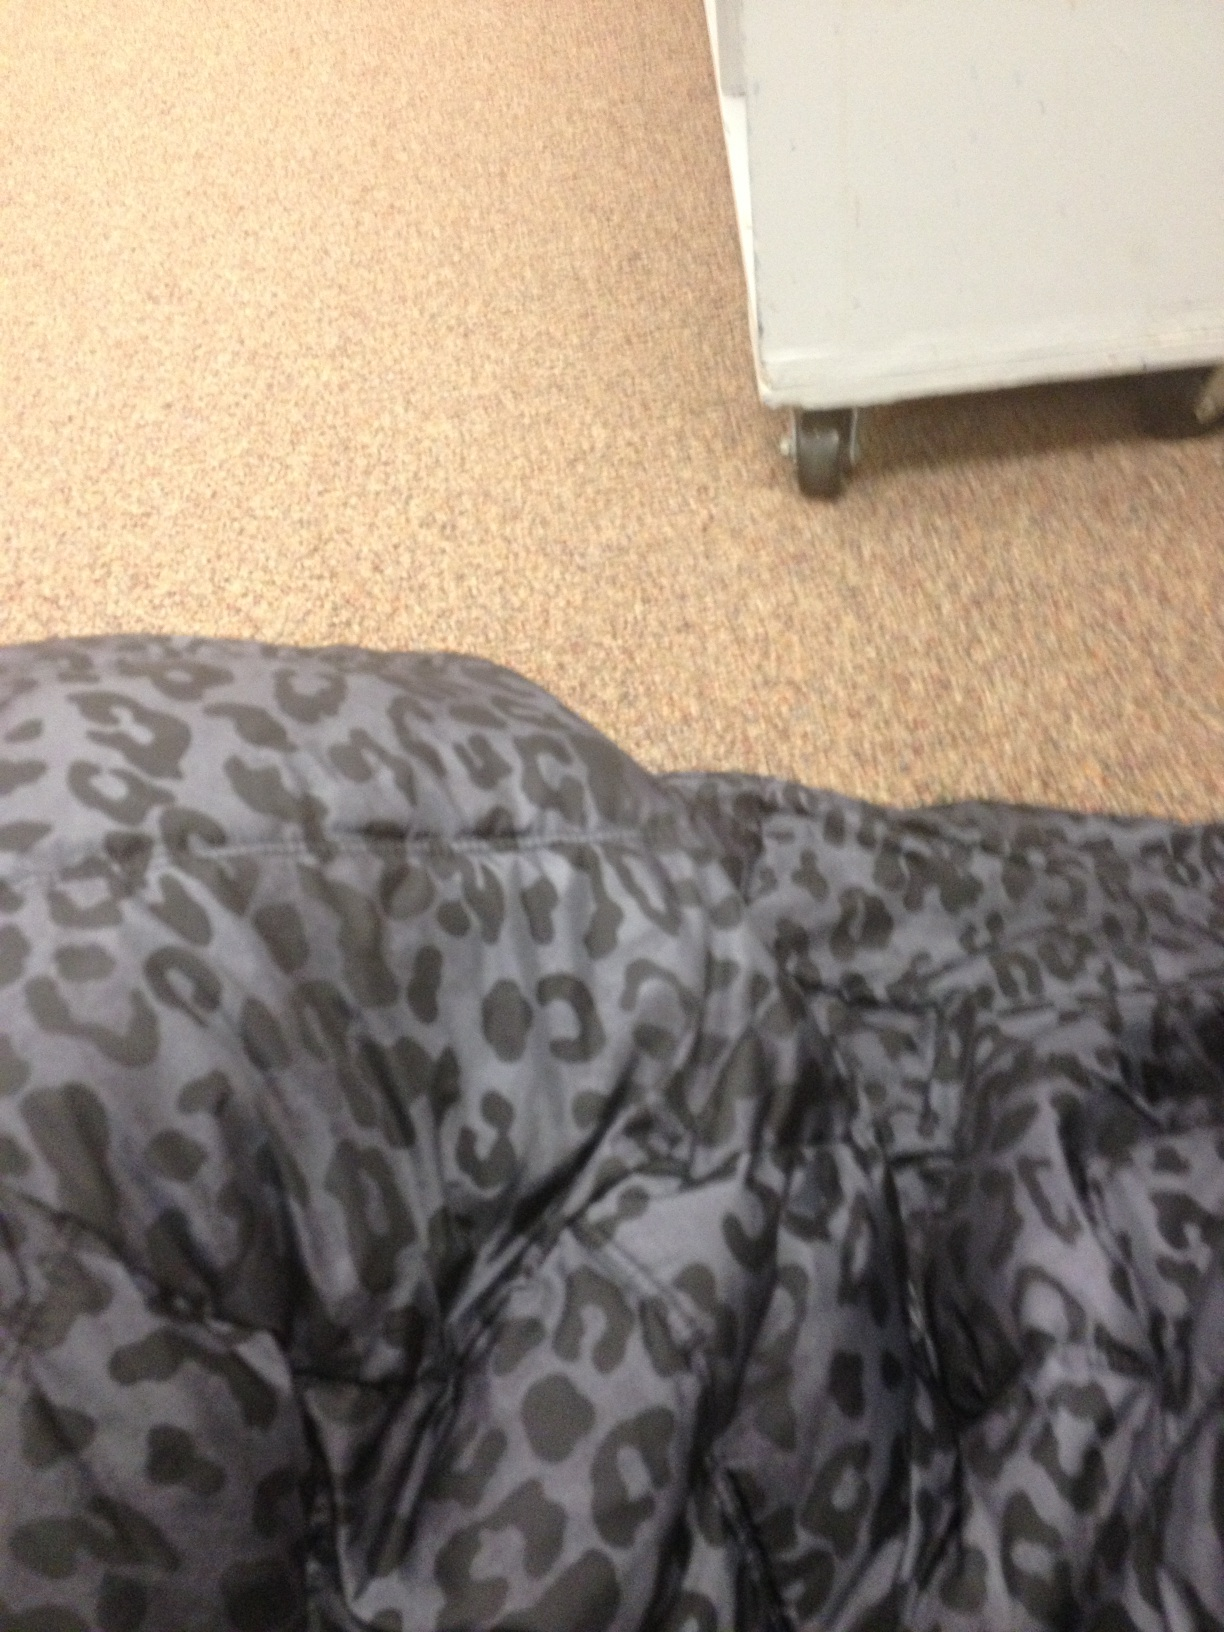What is this? This image features a patterned fabric with a cheetah print design, likely part of a garment or textile product. The specific object is not entirely visible, so it's unclear whether it's clothing, a bag, or another item made with this distinctive animal print. 